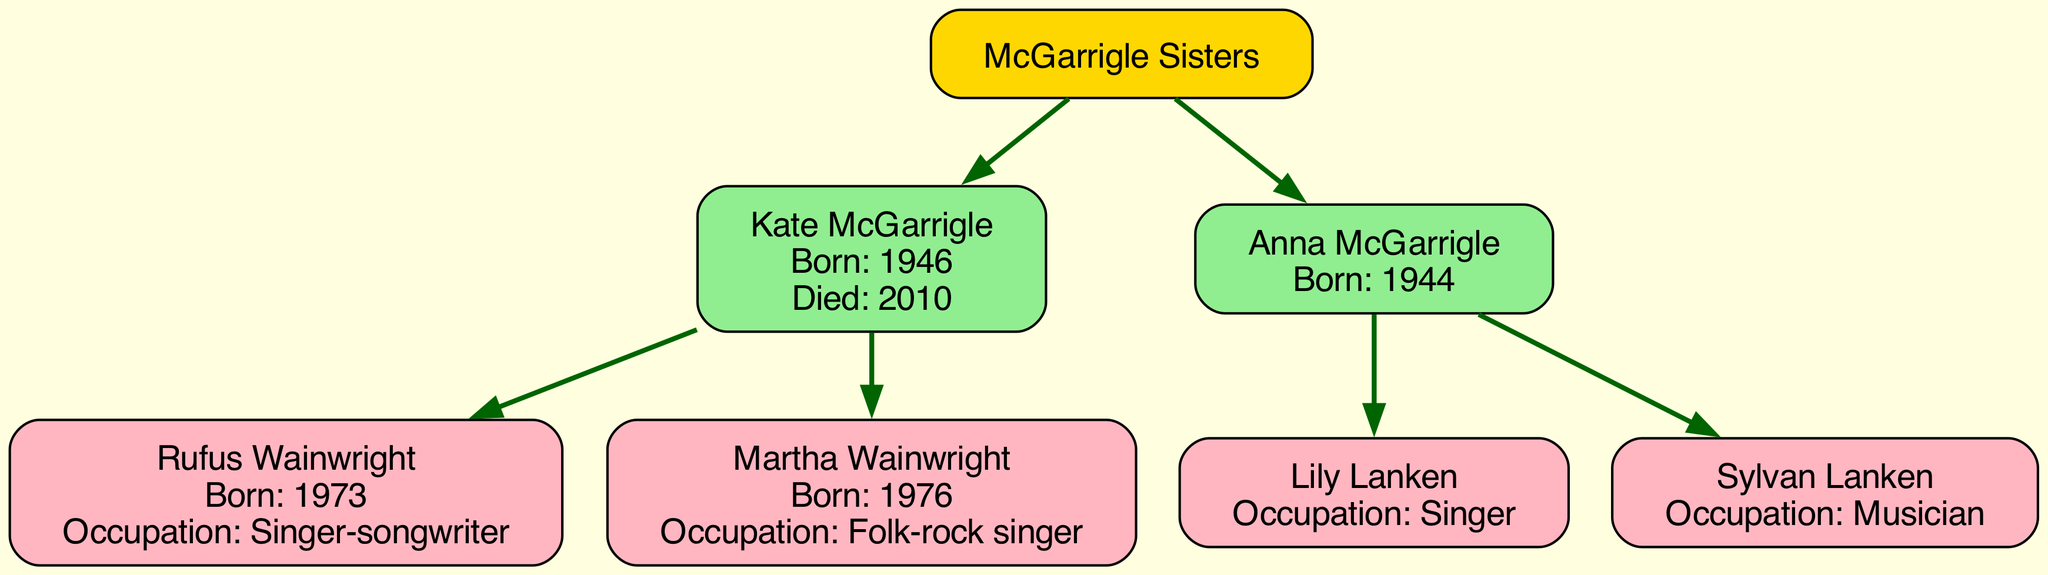What is the birth year of Kate McGarrigle? To find the answer, locate Kate McGarrigle on the diagram. Her birth year is mentioned within her node as "Born: 1946".
Answer: 1946 How many children did Kate McGarrigle have? Examine the children listed under Kate McGarrigle. There are two children listed: Rufus Wainwright and Martha Wainwright. Therefore, the answer is the total count of these children.
Answer: 2 Who is the musician child of Anna McGarrigle? Identify Anna McGarrigle's children from the diagram. The list includes Lily Lanken and Sylvan Lanken. Since the question specifies "musician," refer to Sylvan Lanken who is labeled as a "Musician".
Answer: Sylvan Lanken What is the occupation of Martha Wainwright? Look for Martha Wainwright's name on the diagram. Her occupation is noted as "Folk-rock singer".
Answer: Folk-rock singer Who are the parents of Rufus Wainwright? To answer, first find Rufus Wainwright on the diagram. His parentage can be traced back to the McGarrigle sisters. By checking the nodes linked to Rufus, it shows that his mother is Kate McGarrigle, revealing that he is the child of her specifically.
Answer: Kate McGarrigle Which sister was born first? Analyze the birth years of the two sisters: Kate McGarrigle was born in 1946 and Anna McGarrigle was born in 1944. Since 1944 is earlier than 1946, Anna is the first-born.
Answer: Anna McGarrigle What is the total number of nodes in the family tree? Count all the nodes including both McGarrigle sisters, their offspring, and the root node. The diagram includes one root node, two sister nodes, and four children nodes, totaling seven.
Answer: 7 Who is the offspring of Kate McGarrigle with the birth year of 1976? Look at Kate McGarrigle's children. The children are Rufus Wainwright (born 1973) and Martha Wainwright (born 1976). The question specifies the birth year of 1976, which corresponds to Martha Wainwright.
Answer: Martha Wainwright What color represents the McGarrigle sisters in the diagram? Inspect the color attributes assigned in the diagram. The nodes for the McGarrigle sisters (root and children nodes) are filled with light green.
Answer: Light green 